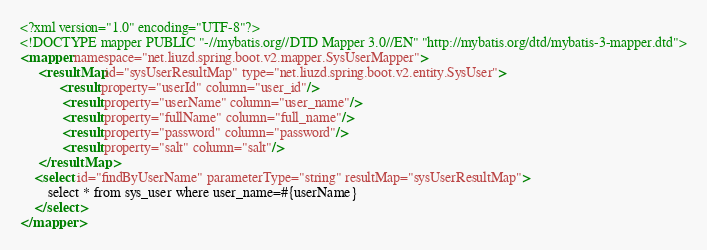<code> <loc_0><loc_0><loc_500><loc_500><_XML_><?xml version="1.0" encoding="UTF-8"?>
<!DOCTYPE mapper PUBLIC "-//mybatis.org//DTD Mapper 3.0//EN" "http://mybatis.org/dtd/mybatis-3-mapper.dtd">
<mapper namespace="net.liuzd.spring.boot.v2.mapper.SysUserMapper">
	 <resultMap id="sysUserResultMap" type="net.liuzd.spring.boot.v2.entity.SysUser">
	 	   <result property="userId" column="user_id"/>
        	<result property="userName" column="user_name"/>	 
        	<result property="fullName" column="full_name"/>
        	<result property="password" column="password"/>	 
        	<result property="salt" column="salt"/>	 
	 </resultMap>
    <select id="findByUserName" parameterType="string" resultMap="sysUserResultMap">
        select * from sys_user where user_name=#{userName}
    </select>
</mapper></code> 